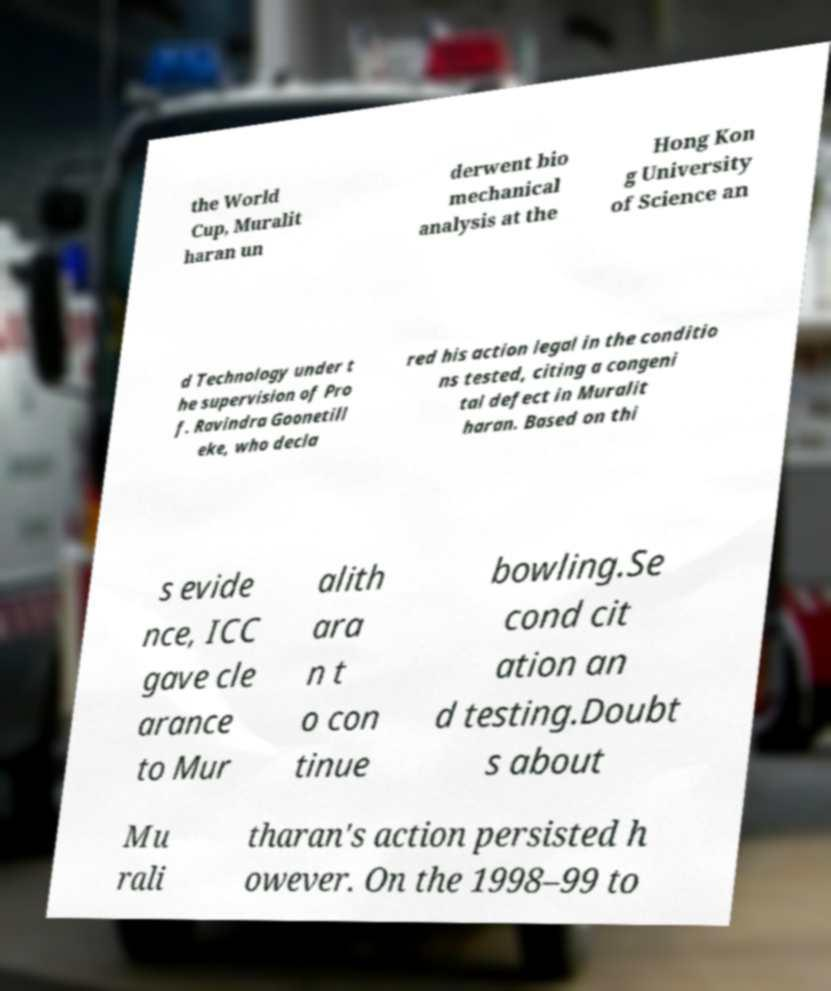Please identify and transcribe the text found in this image. the World Cup, Muralit haran un derwent bio mechanical analysis at the Hong Kon g University of Science an d Technology under t he supervision of Pro f. Ravindra Goonetill eke, who decla red his action legal in the conditio ns tested, citing a congeni tal defect in Muralit haran. Based on thi s evide nce, ICC gave cle arance to Mur alith ara n t o con tinue bowling.Se cond cit ation an d testing.Doubt s about Mu rali tharan's action persisted h owever. On the 1998–99 to 